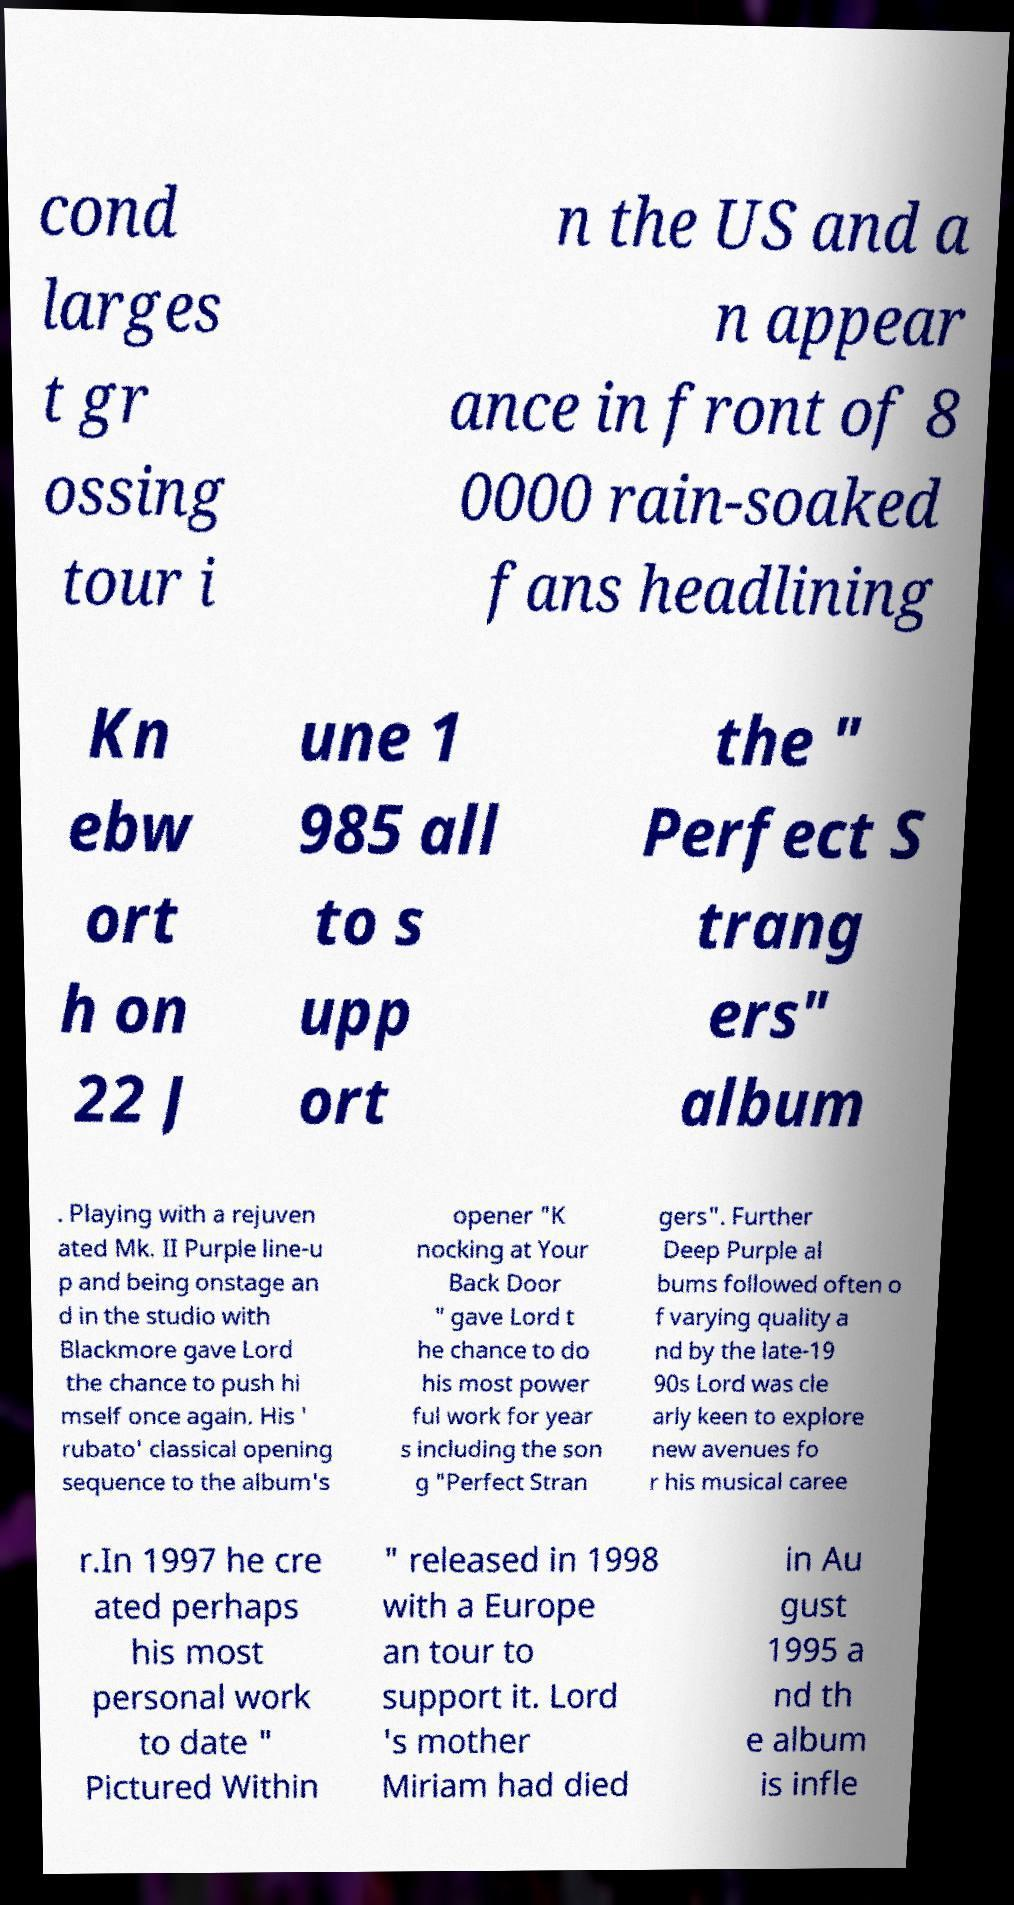Can you accurately transcribe the text from the provided image for me? cond larges t gr ossing tour i n the US and a n appear ance in front of 8 0000 rain-soaked fans headlining Kn ebw ort h on 22 J une 1 985 all to s upp ort the " Perfect S trang ers" album . Playing with a rejuven ated Mk. II Purple line-u p and being onstage an d in the studio with Blackmore gave Lord the chance to push hi mself once again. His ' rubato' classical opening sequence to the album's opener "K nocking at Your Back Door " gave Lord t he chance to do his most power ful work for year s including the son g "Perfect Stran gers". Further Deep Purple al bums followed often o f varying quality a nd by the late-19 90s Lord was cle arly keen to explore new avenues fo r his musical caree r.In 1997 he cre ated perhaps his most personal work to date " Pictured Within " released in 1998 with a Europe an tour to support it. Lord 's mother Miriam had died in Au gust 1995 a nd th e album is infle 